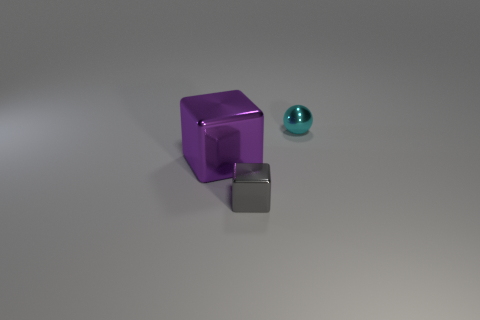Add 1 tiny cubes. How many objects exist? 4 Subtract 1 cubes. How many cubes are left? 1 Subtract all cubes. How many objects are left? 1 Add 1 small red shiny blocks. How many small red shiny blocks exist? 1 Subtract 0 blue blocks. How many objects are left? 3 Subtract all small blocks. Subtract all small cubes. How many objects are left? 1 Add 3 metallic balls. How many metallic balls are left? 4 